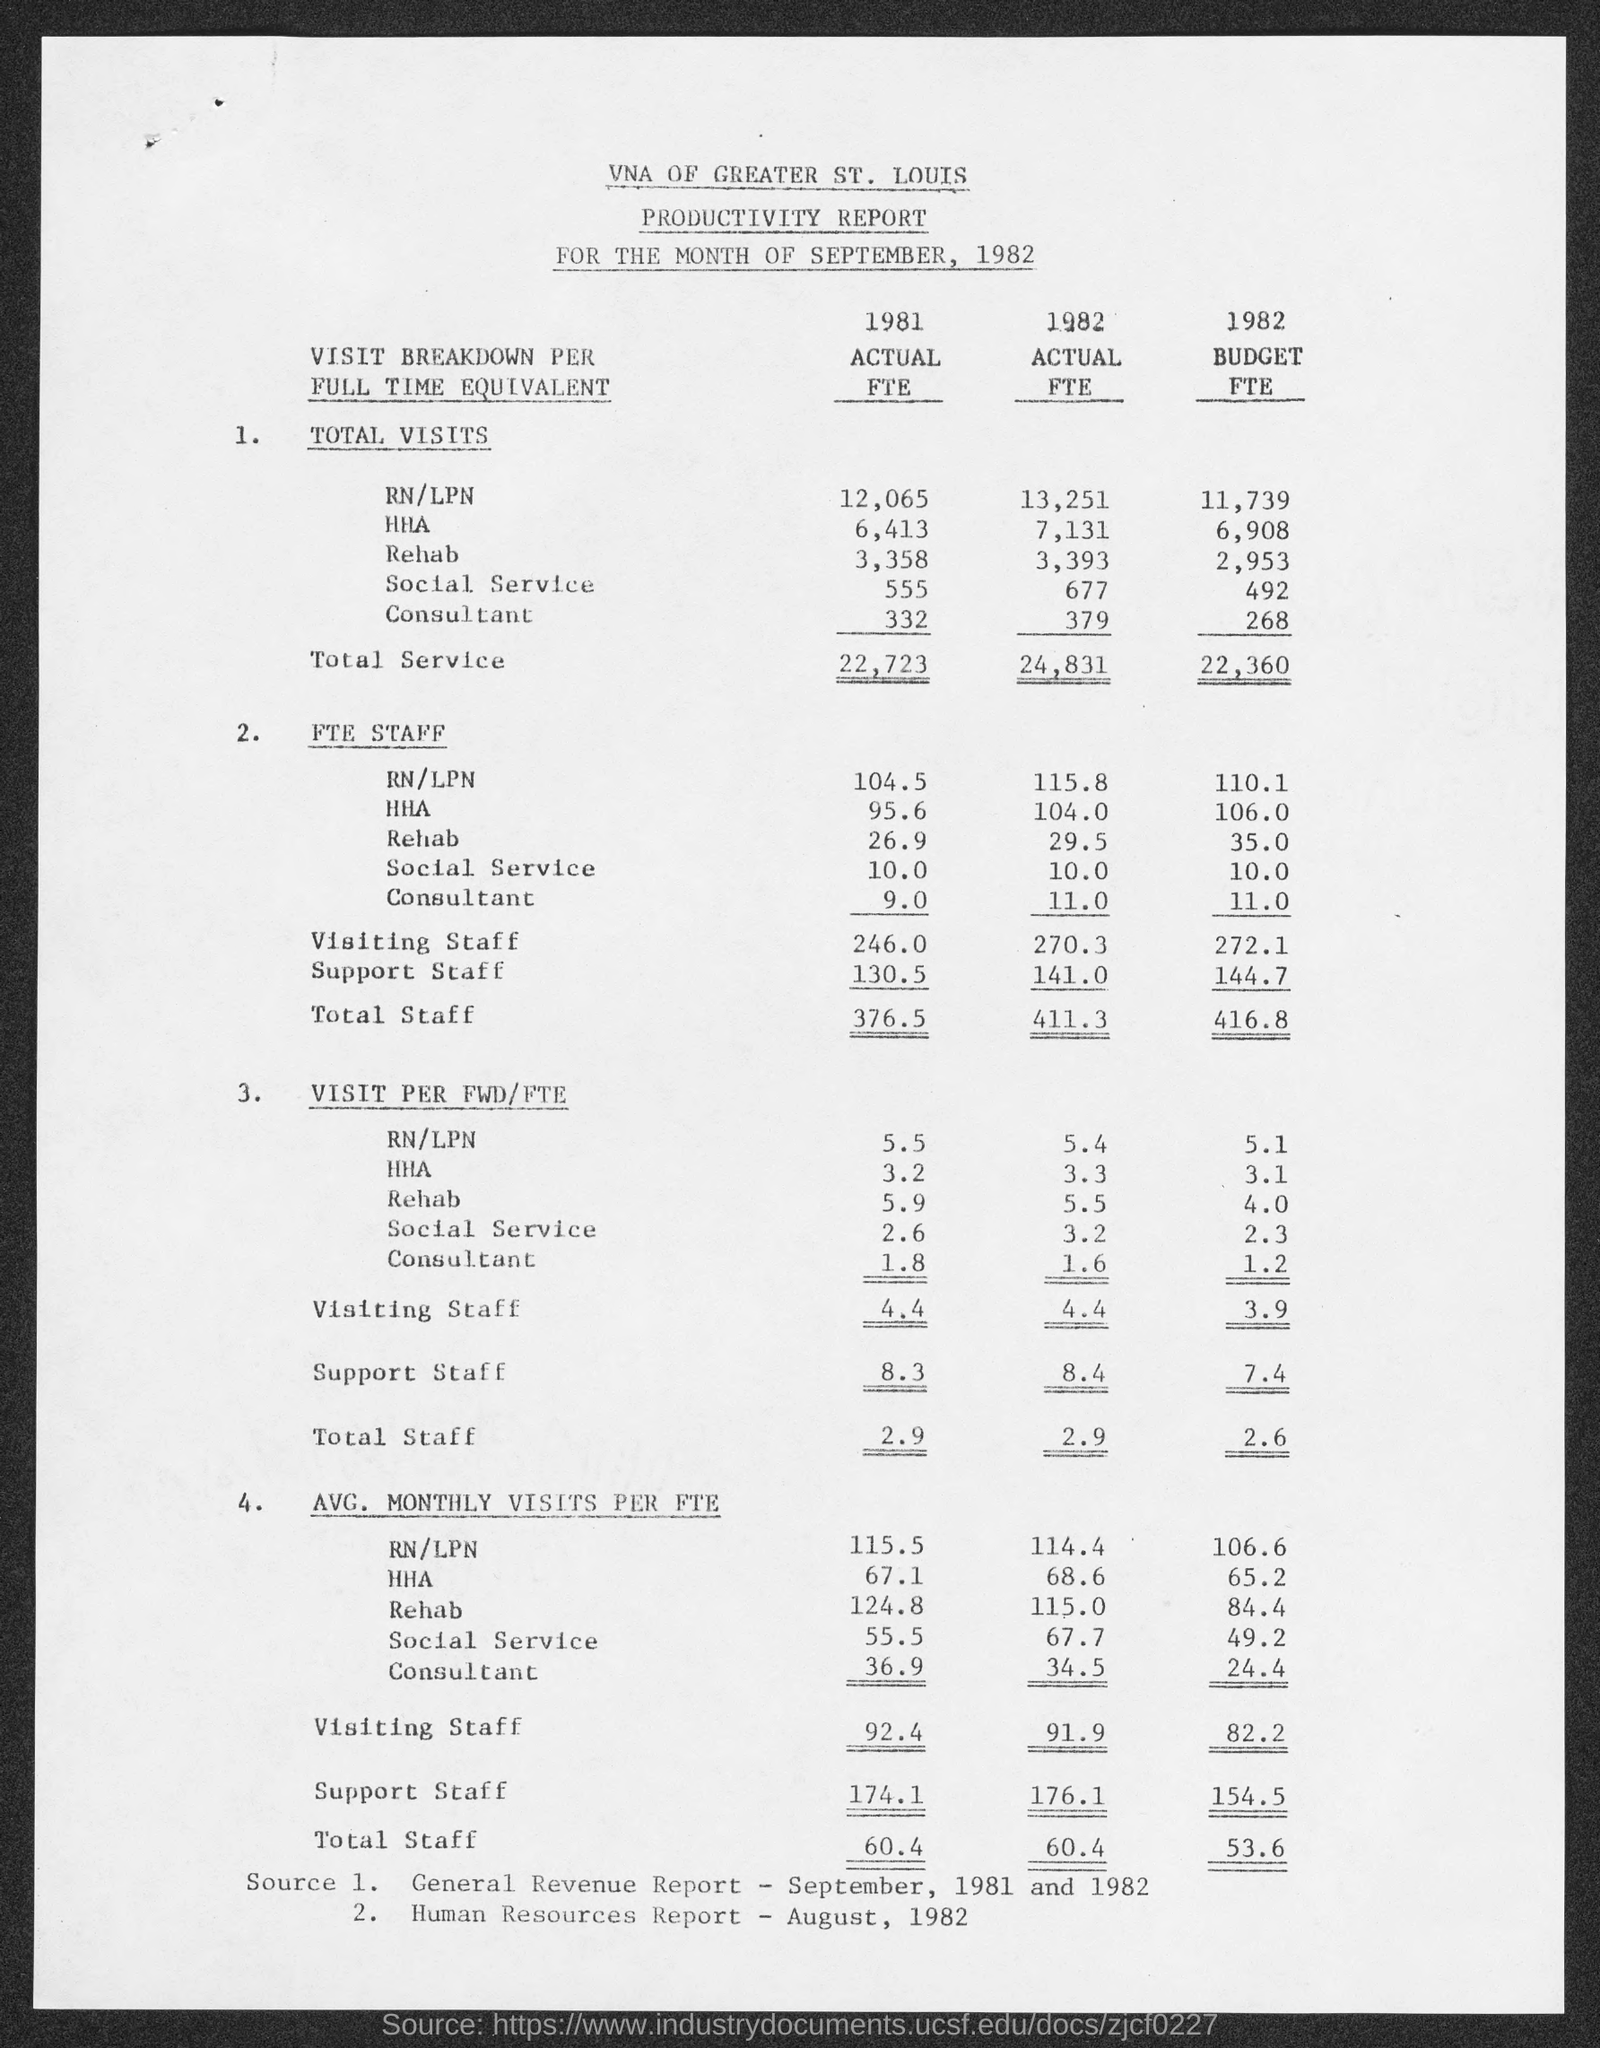Give some essential details in this illustration. We are unsure of the exact average number of visiting staff in the year 1981, as it was not mentioned in the given form. In the year 1981, the total number of visits to social services was 555. In the year 1982, the total value of services was 24,831. In the year 1981, the total number of staff was 376.5 FTEs. In the year 1981, the value of total service was 22,723. 